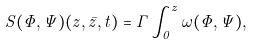Convert formula to latex. <formula><loc_0><loc_0><loc_500><loc_500>S ( \Phi , \Psi ) ( z , \bar { z } , t ) = \Gamma \int _ { 0 } ^ { z } \omega ( \Phi , \Psi ) ,</formula> 